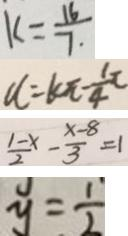Convert formula to latex. <formula><loc_0><loc_0><loc_500><loc_500>k = \frac { 1 6 } { 7 } 
 u = k \pi - \frac { 1 } { 4 } \pi 
 \frac { 1 - x } { 2 } - \frac { x - 8 } { 3 } = 1 
 y = \frac { 1 } { 2 }</formula> 